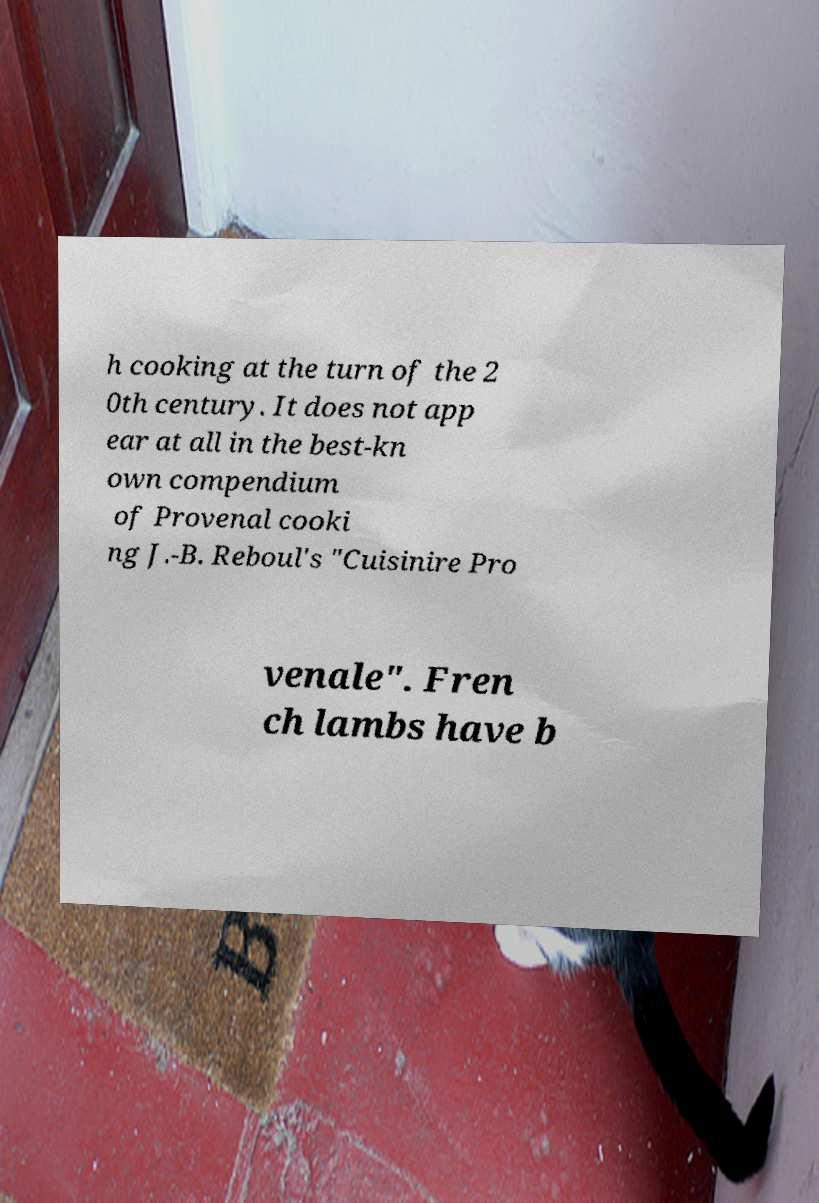There's text embedded in this image that I need extracted. Can you transcribe it verbatim? h cooking at the turn of the 2 0th century. It does not app ear at all in the best-kn own compendium of Provenal cooki ng J.-B. Reboul's "Cuisinire Pro venale". Fren ch lambs have b 